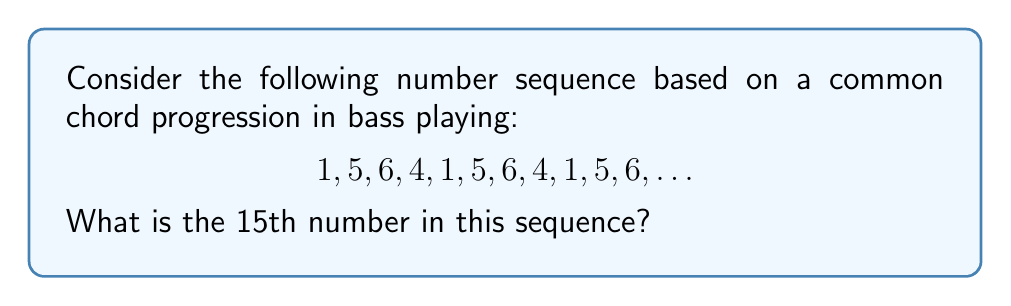What is the answer to this math problem? Let's break this down step-by-step:

1) First, we need to identify the pattern in the sequence. As an aspiring bass player, you might recognize this as a I-V-vi-IV chord progression, which is very common in popular music.

2) The sequence repeats every 4 numbers: 1, 5, 6, 4

3) To find the 15th number, we need to determine which position in the pattern it corresponds to:

   $15 \div 4 = 3$ remainder $3$

4) This tells us that the 15th number is in the 3rd position of the pattern (because the remainder is 3).

5) Looking at our pattern (1, 5, 6, 4), we can see that the 3rd position corresponds to the number 6.

Therefore, the 15th number in the sequence is 6.
Answer: 6 